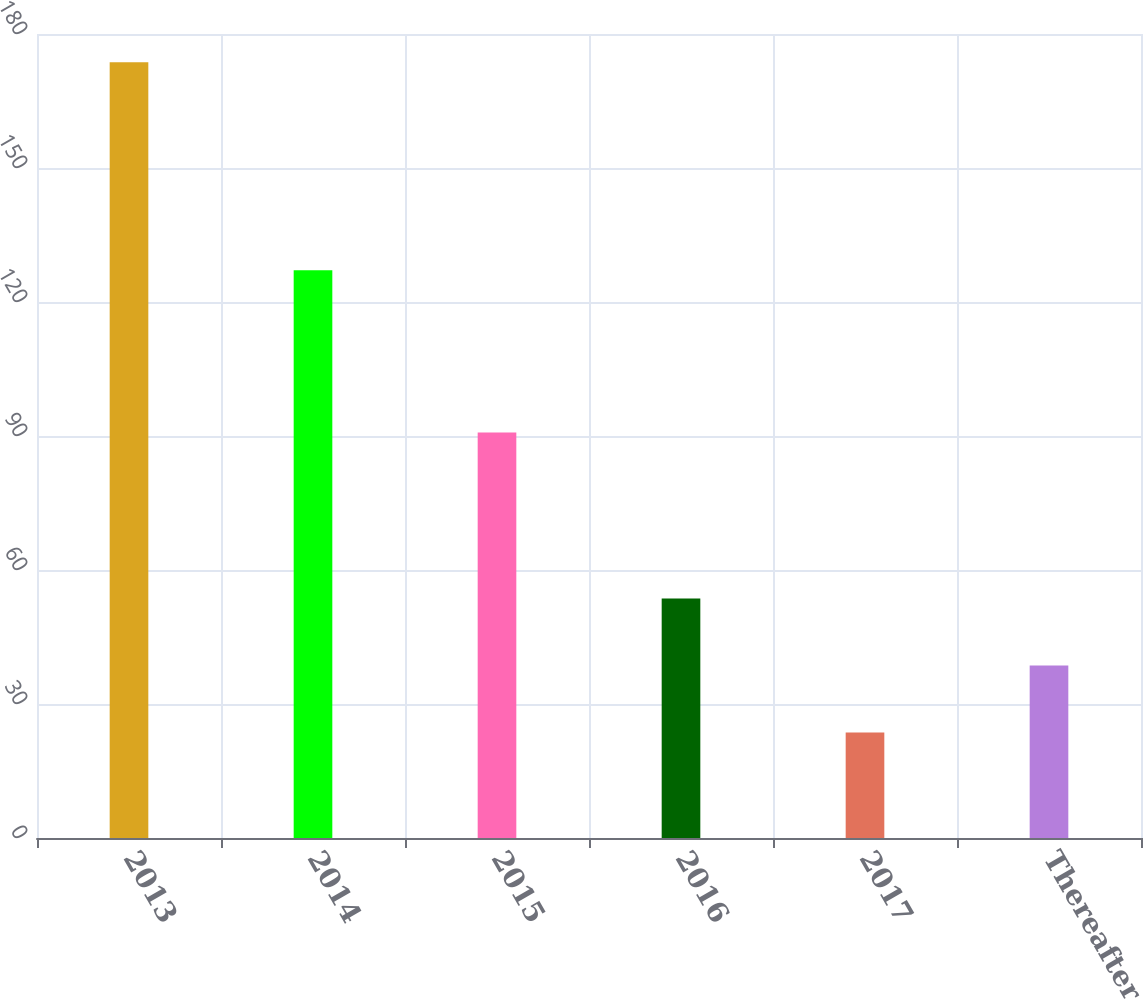Convert chart to OTSL. <chart><loc_0><loc_0><loc_500><loc_500><bar_chart><fcel>2013<fcel>2014<fcel>2015<fcel>2016<fcel>2017<fcel>Thereafter<nl><fcel>173.7<fcel>127.1<fcel>90.8<fcel>53.62<fcel>23.6<fcel>38.61<nl></chart> 